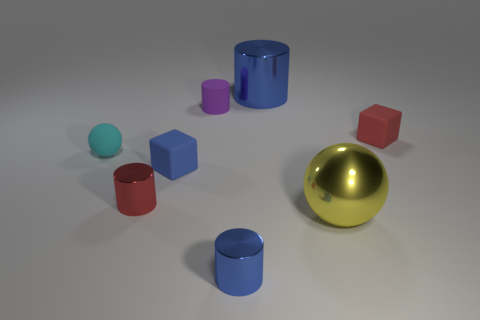Subtract 1 cylinders. How many cylinders are left? 3 Add 1 large metal cylinders. How many objects exist? 9 Subtract all cubes. How many objects are left? 6 Subtract all small rubber blocks. Subtract all big yellow shiny spheres. How many objects are left? 5 Add 6 big balls. How many big balls are left? 7 Add 4 purple things. How many purple things exist? 5 Subtract 0 brown spheres. How many objects are left? 8 